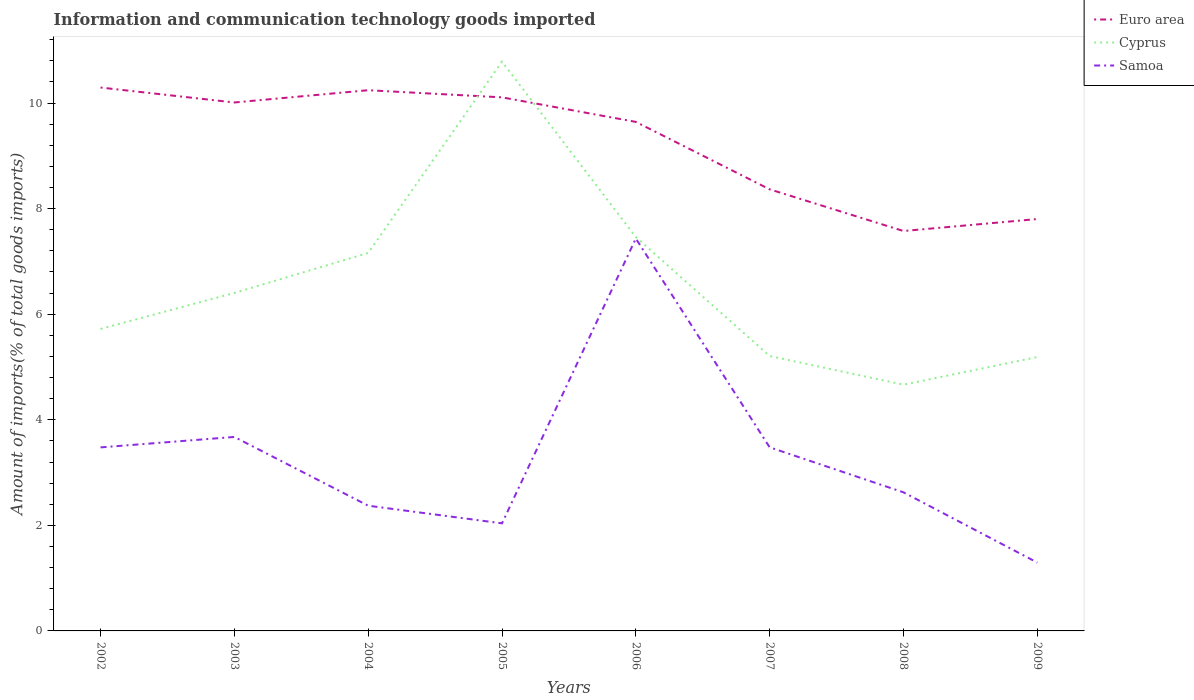How many different coloured lines are there?
Provide a succinct answer. 3. Across all years, what is the maximum amount of goods imported in Euro area?
Provide a short and direct response. 7.58. What is the total amount of goods imported in Cyprus in the graph?
Provide a short and direct response. 6.12. What is the difference between the highest and the second highest amount of goods imported in Cyprus?
Provide a short and direct response. 6.12. What is the difference between the highest and the lowest amount of goods imported in Samoa?
Ensure brevity in your answer.  4. How are the legend labels stacked?
Give a very brief answer. Vertical. What is the title of the graph?
Offer a very short reply. Information and communication technology goods imported. What is the label or title of the Y-axis?
Offer a terse response. Amount of imports(% of total goods imports). What is the Amount of imports(% of total goods imports) in Euro area in 2002?
Offer a very short reply. 10.29. What is the Amount of imports(% of total goods imports) of Cyprus in 2002?
Your answer should be very brief. 5.72. What is the Amount of imports(% of total goods imports) of Samoa in 2002?
Offer a very short reply. 3.48. What is the Amount of imports(% of total goods imports) of Euro area in 2003?
Your answer should be compact. 10.01. What is the Amount of imports(% of total goods imports) of Cyprus in 2003?
Offer a very short reply. 6.4. What is the Amount of imports(% of total goods imports) in Samoa in 2003?
Offer a terse response. 3.67. What is the Amount of imports(% of total goods imports) of Euro area in 2004?
Provide a succinct answer. 10.24. What is the Amount of imports(% of total goods imports) of Cyprus in 2004?
Provide a succinct answer. 7.16. What is the Amount of imports(% of total goods imports) of Samoa in 2004?
Keep it short and to the point. 2.37. What is the Amount of imports(% of total goods imports) in Euro area in 2005?
Provide a succinct answer. 10.11. What is the Amount of imports(% of total goods imports) of Cyprus in 2005?
Make the answer very short. 10.78. What is the Amount of imports(% of total goods imports) in Samoa in 2005?
Provide a succinct answer. 2.04. What is the Amount of imports(% of total goods imports) of Euro area in 2006?
Your response must be concise. 9.64. What is the Amount of imports(% of total goods imports) in Cyprus in 2006?
Your answer should be compact. 7.46. What is the Amount of imports(% of total goods imports) of Samoa in 2006?
Offer a very short reply. 7.43. What is the Amount of imports(% of total goods imports) in Euro area in 2007?
Keep it short and to the point. 8.37. What is the Amount of imports(% of total goods imports) of Cyprus in 2007?
Provide a short and direct response. 5.21. What is the Amount of imports(% of total goods imports) in Samoa in 2007?
Provide a short and direct response. 3.48. What is the Amount of imports(% of total goods imports) in Euro area in 2008?
Offer a terse response. 7.58. What is the Amount of imports(% of total goods imports) of Cyprus in 2008?
Provide a short and direct response. 4.66. What is the Amount of imports(% of total goods imports) of Samoa in 2008?
Provide a short and direct response. 2.63. What is the Amount of imports(% of total goods imports) of Euro area in 2009?
Give a very brief answer. 7.8. What is the Amount of imports(% of total goods imports) of Cyprus in 2009?
Give a very brief answer. 5.19. What is the Amount of imports(% of total goods imports) in Samoa in 2009?
Provide a short and direct response. 1.29. Across all years, what is the maximum Amount of imports(% of total goods imports) of Euro area?
Make the answer very short. 10.29. Across all years, what is the maximum Amount of imports(% of total goods imports) in Cyprus?
Keep it short and to the point. 10.78. Across all years, what is the maximum Amount of imports(% of total goods imports) of Samoa?
Offer a very short reply. 7.43. Across all years, what is the minimum Amount of imports(% of total goods imports) of Euro area?
Your answer should be very brief. 7.58. Across all years, what is the minimum Amount of imports(% of total goods imports) in Cyprus?
Your response must be concise. 4.66. Across all years, what is the minimum Amount of imports(% of total goods imports) of Samoa?
Offer a terse response. 1.29. What is the total Amount of imports(% of total goods imports) of Euro area in the graph?
Make the answer very short. 74.04. What is the total Amount of imports(% of total goods imports) in Cyprus in the graph?
Offer a very short reply. 52.59. What is the total Amount of imports(% of total goods imports) in Samoa in the graph?
Ensure brevity in your answer.  26.39. What is the difference between the Amount of imports(% of total goods imports) of Euro area in 2002 and that in 2003?
Your answer should be compact. 0.28. What is the difference between the Amount of imports(% of total goods imports) of Cyprus in 2002 and that in 2003?
Provide a short and direct response. -0.68. What is the difference between the Amount of imports(% of total goods imports) of Samoa in 2002 and that in 2003?
Offer a terse response. -0.2. What is the difference between the Amount of imports(% of total goods imports) of Euro area in 2002 and that in 2004?
Provide a succinct answer. 0.05. What is the difference between the Amount of imports(% of total goods imports) in Cyprus in 2002 and that in 2004?
Give a very brief answer. -1.44. What is the difference between the Amount of imports(% of total goods imports) in Samoa in 2002 and that in 2004?
Your answer should be compact. 1.1. What is the difference between the Amount of imports(% of total goods imports) in Euro area in 2002 and that in 2005?
Offer a terse response. 0.19. What is the difference between the Amount of imports(% of total goods imports) of Cyprus in 2002 and that in 2005?
Provide a succinct answer. -5.06. What is the difference between the Amount of imports(% of total goods imports) of Samoa in 2002 and that in 2005?
Provide a succinct answer. 1.44. What is the difference between the Amount of imports(% of total goods imports) of Euro area in 2002 and that in 2006?
Ensure brevity in your answer.  0.65. What is the difference between the Amount of imports(% of total goods imports) of Cyprus in 2002 and that in 2006?
Offer a very short reply. -1.74. What is the difference between the Amount of imports(% of total goods imports) of Samoa in 2002 and that in 2006?
Ensure brevity in your answer.  -3.96. What is the difference between the Amount of imports(% of total goods imports) of Euro area in 2002 and that in 2007?
Make the answer very short. 1.93. What is the difference between the Amount of imports(% of total goods imports) of Cyprus in 2002 and that in 2007?
Keep it short and to the point. 0.51. What is the difference between the Amount of imports(% of total goods imports) of Samoa in 2002 and that in 2007?
Ensure brevity in your answer.  -0. What is the difference between the Amount of imports(% of total goods imports) of Euro area in 2002 and that in 2008?
Give a very brief answer. 2.72. What is the difference between the Amount of imports(% of total goods imports) in Cyprus in 2002 and that in 2008?
Make the answer very short. 1.06. What is the difference between the Amount of imports(% of total goods imports) in Samoa in 2002 and that in 2008?
Offer a very short reply. 0.85. What is the difference between the Amount of imports(% of total goods imports) of Euro area in 2002 and that in 2009?
Offer a very short reply. 2.49. What is the difference between the Amount of imports(% of total goods imports) in Cyprus in 2002 and that in 2009?
Your answer should be compact. 0.53. What is the difference between the Amount of imports(% of total goods imports) of Samoa in 2002 and that in 2009?
Offer a terse response. 2.18. What is the difference between the Amount of imports(% of total goods imports) in Euro area in 2003 and that in 2004?
Offer a very short reply. -0.23. What is the difference between the Amount of imports(% of total goods imports) in Cyprus in 2003 and that in 2004?
Your answer should be very brief. -0.76. What is the difference between the Amount of imports(% of total goods imports) in Samoa in 2003 and that in 2004?
Make the answer very short. 1.3. What is the difference between the Amount of imports(% of total goods imports) of Euro area in 2003 and that in 2005?
Ensure brevity in your answer.  -0.1. What is the difference between the Amount of imports(% of total goods imports) of Cyprus in 2003 and that in 2005?
Provide a short and direct response. -4.38. What is the difference between the Amount of imports(% of total goods imports) in Samoa in 2003 and that in 2005?
Offer a very short reply. 1.64. What is the difference between the Amount of imports(% of total goods imports) of Euro area in 2003 and that in 2006?
Provide a short and direct response. 0.37. What is the difference between the Amount of imports(% of total goods imports) in Cyprus in 2003 and that in 2006?
Your answer should be very brief. -1.06. What is the difference between the Amount of imports(% of total goods imports) in Samoa in 2003 and that in 2006?
Provide a short and direct response. -3.76. What is the difference between the Amount of imports(% of total goods imports) in Euro area in 2003 and that in 2007?
Provide a short and direct response. 1.65. What is the difference between the Amount of imports(% of total goods imports) of Cyprus in 2003 and that in 2007?
Your answer should be very brief. 1.2. What is the difference between the Amount of imports(% of total goods imports) in Samoa in 2003 and that in 2007?
Offer a terse response. 0.2. What is the difference between the Amount of imports(% of total goods imports) in Euro area in 2003 and that in 2008?
Your answer should be very brief. 2.43. What is the difference between the Amount of imports(% of total goods imports) of Cyprus in 2003 and that in 2008?
Ensure brevity in your answer.  1.74. What is the difference between the Amount of imports(% of total goods imports) of Samoa in 2003 and that in 2008?
Keep it short and to the point. 1.05. What is the difference between the Amount of imports(% of total goods imports) in Euro area in 2003 and that in 2009?
Your answer should be compact. 2.21. What is the difference between the Amount of imports(% of total goods imports) in Cyprus in 2003 and that in 2009?
Provide a short and direct response. 1.22. What is the difference between the Amount of imports(% of total goods imports) in Samoa in 2003 and that in 2009?
Keep it short and to the point. 2.38. What is the difference between the Amount of imports(% of total goods imports) of Euro area in 2004 and that in 2005?
Ensure brevity in your answer.  0.14. What is the difference between the Amount of imports(% of total goods imports) of Cyprus in 2004 and that in 2005?
Provide a succinct answer. -3.62. What is the difference between the Amount of imports(% of total goods imports) of Samoa in 2004 and that in 2005?
Keep it short and to the point. 0.33. What is the difference between the Amount of imports(% of total goods imports) in Euro area in 2004 and that in 2006?
Your answer should be compact. 0.6. What is the difference between the Amount of imports(% of total goods imports) of Cyprus in 2004 and that in 2006?
Provide a succinct answer. -0.3. What is the difference between the Amount of imports(% of total goods imports) in Samoa in 2004 and that in 2006?
Give a very brief answer. -5.06. What is the difference between the Amount of imports(% of total goods imports) of Euro area in 2004 and that in 2007?
Ensure brevity in your answer.  1.88. What is the difference between the Amount of imports(% of total goods imports) of Cyprus in 2004 and that in 2007?
Ensure brevity in your answer.  1.95. What is the difference between the Amount of imports(% of total goods imports) of Samoa in 2004 and that in 2007?
Offer a very short reply. -1.11. What is the difference between the Amount of imports(% of total goods imports) of Euro area in 2004 and that in 2008?
Keep it short and to the point. 2.67. What is the difference between the Amount of imports(% of total goods imports) of Cyprus in 2004 and that in 2008?
Give a very brief answer. 2.5. What is the difference between the Amount of imports(% of total goods imports) of Samoa in 2004 and that in 2008?
Offer a very short reply. -0.25. What is the difference between the Amount of imports(% of total goods imports) in Euro area in 2004 and that in 2009?
Offer a terse response. 2.44. What is the difference between the Amount of imports(% of total goods imports) of Cyprus in 2004 and that in 2009?
Your answer should be very brief. 1.97. What is the difference between the Amount of imports(% of total goods imports) in Samoa in 2004 and that in 2009?
Your answer should be very brief. 1.08. What is the difference between the Amount of imports(% of total goods imports) in Euro area in 2005 and that in 2006?
Make the answer very short. 0.46. What is the difference between the Amount of imports(% of total goods imports) of Cyprus in 2005 and that in 2006?
Give a very brief answer. 3.32. What is the difference between the Amount of imports(% of total goods imports) in Samoa in 2005 and that in 2006?
Make the answer very short. -5.4. What is the difference between the Amount of imports(% of total goods imports) of Euro area in 2005 and that in 2007?
Keep it short and to the point. 1.74. What is the difference between the Amount of imports(% of total goods imports) in Cyprus in 2005 and that in 2007?
Your response must be concise. 5.58. What is the difference between the Amount of imports(% of total goods imports) in Samoa in 2005 and that in 2007?
Give a very brief answer. -1.44. What is the difference between the Amount of imports(% of total goods imports) of Euro area in 2005 and that in 2008?
Offer a terse response. 2.53. What is the difference between the Amount of imports(% of total goods imports) in Cyprus in 2005 and that in 2008?
Your answer should be compact. 6.12. What is the difference between the Amount of imports(% of total goods imports) in Samoa in 2005 and that in 2008?
Make the answer very short. -0.59. What is the difference between the Amount of imports(% of total goods imports) in Euro area in 2005 and that in 2009?
Your response must be concise. 2.31. What is the difference between the Amount of imports(% of total goods imports) in Cyprus in 2005 and that in 2009?
Provide a succinct answer. 5.6. What is the difference between the Amount of imports(% of total goods imports) of Samoa in 2005 and that in 2009?
Ensure brevity in your answer.  0.74. What is the difference between the Amount of imports(% of total goods imports) in Euro area in 2006 and that in 2007?
Provide a succinct answer. 1.28. What is the difference between the Amount of imports(% of total goods imports) in Cyprus in 2006 and that in 2007?
Your response must be concise. 2.25. What is the difference between the Amount of imports(% of total goods imports) in Samoa in 2006 and that in 2007?
Ensure brevity in your answer.  3.96. What is the difference between the Amount of imports(% of total goods imports) in Euro area in 2006 and that in 2008?
Keep it short and to the point. 2.07. What is the difference between the Amount of imports(% of total goods imports) of Cyprus in 2006 and that in 2008?
Keep it short and to the point. 2.8. What is the difference between the Amount of imports(% of total goods imports) in Samoa in 2006 and that in 2008?
Provide a short and direct response. 4.81. What is the difference between the Amount of imports(% of total goods imports) of Euro area in 2006 and that in 2009?
Your answer should be very brief. 1.84. What is the difference between the Amount of imports(% of total goods imports) of Cyprus in 2006 and that in 2009?
Provide a short and direct response. 2.27. What is the difference between the Amount of imports(% of total goods imports) in Samoa in 2006 and that in 2009?
Give a very brief answer. 6.14. What is the difference between the Amount of imports(% of total goods imports) in Euro area in 2007 and that in 2008?
Your answer should be very brief. 0.79. What is the difference between the Amount of imports(% of total goods imports) in Cyprus in 2007 and that in 2008?
Provide a succinct answer. 0.54. What is the difference between the Amount of imports(% of total goods imports) in Samoa in 2007 and that in 2008?
Give a very brief answer. 0.85. What is the difference between the Amount of imports(% of total goods imports) in Euro area in 2007 and that in 2009?
Keep it short and to the point. 0.56. What is the difference between the Amount of imports(% of total goods imports) of Cyprus in 2007 and that in 2009?
Your answer should be compact. 0.02. What is the difference between the Amount of imports(% of total goods imports) in Samoa in 2007 and that in 2009?
Offer a terse response. 2.18. What is the difference between the Amount of imports(% of total goods imports) in Euro area in 2008 and that in 2009?
Your answer should be very brief. -0.23. What is the difference between the Amount of imports(% of total goods imports) in Cyprus in 2008 and that in 2009?
Provide a short and direct response. -0.52. What is the difference between the Amount of imports(% of total goods imports) of Samoa in 2008 and that in 2009?
Offer a terse response. 1.33. What is the difference between the Amount of imports(% of total goods imports) of Euro area in 2002 and the Amount of imports(% of total goods imports) of Cyprus in 2003?
Ensure brevity in your answer.  3.89. What is the difference between the Amount of imports(% of total goods imports) in Euro area in 2002 and the Amount of imports(% of total goods imports) in Samoa in 2003?
Your response must be concise. 6.62. What is the difference between the Amount of imports(% of total goods imports) of Cyprus in 2002 and the Amount of imports(% of total goods imports) of Samoa in 2003?
Keep it short and to the point. 2.05. What is the difference between the Amount of imports(% of total goods imports) in Euro area in 2002 and the Amount of imports(% of total goods imports) in Cyprus in 2004?
Give a very brief answer. 3.13. What is the difference between the Amount of imports(% of total goods imports) of Euro area in 2002 and the Amount of imports(% of total goods imports) of Samoa in 2004?
Make the answer very short. 7.92. What is the difference between the Amount of imports(% of total goods imports) in Cyprus in 2002 and the Amount of imports(% of total goods imports) in Samoa in 2004?
Provide a succinct answer. 3.35. What is the difference between the Amount of imports(% of total goods imports) of Euro area in 2002 and the Amount of imports(% of total goods imports) of Cyprus in 2005?
Offer a very short reply. -0.49. What is the difference between the Amount of imports(% of total goods imports) of Euro area in 2002 and the Amount of imports(% of total goods imports) of Samoa in 2005?
Provide a succinct answer. 8.26. What is the difference between the Amount of imports(% of total goods imports) in Cyprus in 2002 and the Amount of imports(% of total goods imports) in Samoa in 2005?
Give a very brief answer. 3.68. What is the difference between the Amount of imports(% of total goods imports) in Euro area in 2002 and the Amount of imports(% of total goods imports) in Cyprus in 2006?
Make the answer very short. 2.83. What is the difference between the Amount of imports(% of total goods imports) in Euro area in 2002 and the Amount of imports(% of total goods imports) in Samoa in 2006?
Ensure brevity in your answer.  2.86. What is the difference between the Amount of imports(% of total goods imports) in Cyprus in 2002 and the Amount of imports(% of total goods imports) in Samoa in 2006?
Your response must be concise. -1.71. What is the difference between the Amount of imports(% of total goods imports) in Euro area in 2002 and the Amount of imports(% of total goods imports) in Cyprus in 2007?
Give a very brief answer. 5.09. What is the difference between the Amount of imports(% of total goods imports) of Euro area in 2002 and the Amount of imports(% of total goods imports) of Samoa in 2007?
Your answer should be compact. 6.82. What is the difference between the Amount of imports(% of total goods imports) of Cyprus in 2002 and the Amount of imports(% of total goods imports) of Samoa in 2007?
Provide a succinct answer. 2.24. What is the difference between the Amount of imports(% of total goods imports) of Euro area in 2002 and the Amount of imports(% of total goods imports) of Cyprus in 2008?
Your answer should be very brief. 5.63. What is the difference between the Amount of imports(% of total goods imports) of Euro area in 2002 and the Amount of imports(% of total goods imports) of Samoa in 2008?
Provide a succinct answer. 7.67. What is the difference between the Amount of imports(% of total goods imports) of Cyprus in 2002 and the Amount of imports(% of total goods imports) of Samoa in 2008?
Provide a short and direct response. 3.1. What is the difference between the Amount of imports(% of total goods imports) of Euro area in 2002 and the Amount of imports(% of total goods imports) of Cyprus in 2009?
Offer a terse response. 5.11. What is the difference between the Amount of imports(% of total goods imports) of Euro area in 2002 and the Amount of imports(% of total goods imports) of Samoa in 2009?
Ensure brevity in your answer.  9. What is the difference between the Amount of imports(% of total goods imports) of Cyprus in 2002 and the Amount of imports(% of total goods imports) of Samoa in 2009?
Provide a succinct answer. 4.43. What is the difference between the Amount of imports(% of total goods imports) of Euro area in 2003 and the Amount of imports(% of total goods imports) of Cyprus in 2004?
Offer a terse response. 2.85. What is the difference between the Amount of imports(% of total goods imports) of Euro area in 2003 and the Amount of imports(% of total goods imports) of Samoa in 2004?
Your answer should be very brief. 7.64. What is the difference between the Amount of imports(% of total goods imports) of Cyprus in 2003 and the Amount of imports(% of total goods imports) of Samoa in 2004?
Provide a short and direct response. 4.03. What is the difference between the Amount of imports(% of total goods imports) of Euro area in 2003 and the Amount of imports(% of total goods imports) of Cyprus in 2005?
Give a very brief answer. -0.77. What is the difference between the Amount of imports(% of total goods imports) in Euro area in 2003 and the Amount of imports(% of total goods imports) in Samoa in 2005?
Offer a terse response. 7.97. What is the difference between the Amount of imports(% of total goods imports) in Cyprus in 2003 and the Amount of imports(% of total goods imports) in Samoa in 2005?
Provide a succinct answer. 4.36. What is the difference between the Amount of imports(% of total goods imports) in Euro area in 2003 and the Amount of imports(% of total goods imports) in Cyprus in 2006?
Offer a very short reply. 2.55. What is the difference between the Amount of imports(% of total goods imports) in Euro area in 2003 and the Amount of imports(% of total goods imports) in Samoa in 2006?
Your answer should be very brief. 2.58. What is the difference between the Amount of imports(% of total goods imports) of Cyprus in 2003 and the Amount of imports(% of total goods imports) of Samoa in 2006?
Your answer should be very brief. -1.03. What is the difference between the Amount of imports(% of total goods imports) of Euro area in 2003 and the Amount of imports(% of total goods imports) of Cyprus in 2007?
Your answer should be very brief. 4.8. What is the difference between the Amount of imports(% of total goods imports) of Euro area in 2003 and the Amount of imports(% of total goods imports) of Samoa in 2007?
Keep it short and to the point. 6.53. What is the difference between the Amount of imports(% of total goods imports) of Cyprus in 2003 and the Amount of imports(% of total goods imports) of Samoa in 2007?
Ensure brevity in your answer.  2.92. What is the difference between the Amount of imports(% of total goods imports) of Euro area in 2003 and the Amount of imports(% of total goods imports) of Cyprus in 2008?
Your answer should be compact. 5.35. What is the difference between the Amount of imports(% of total goods imports) of Euro area in 2003 and the Amount of imports(% of total goods imports) of Samoa in 2008?
Give a very brief answer. 7.39. What is the difference between the Amount of imports(% of total goods imports) of Cyprus in 2003 and the Amount of imports(% of total goods imports) of Samoa in 2008?
Offer a very short reply. 3.78. What is the difference between the Amount of imports(% of total goods imports) in Euro area in 2003 and the Amount of imports(% of total goods imports) in Cyprus in 2009?
Ensure brevity in your answer.  4.82. What is the difference between the Amount of imports(% of total goods imports) of Euro area in 2003 and the Amount of imports(% of total goods imports) of Samoa in 2009?
Ensure brevity in your answer.  8.72. What is the difference between the Amount of imports(% of total goods imports) in Cyprus in 2003 and the Amount of imports(% of total goods imports) in Samoa in 2009?
Your answer should be very brief. 5.11. What is the difference between the Amount of imports(% of total goods imports) in Euro area in 2004 and the Amount of imports(% of total goods imports) in Cyprus in 2005?
Provide a succinct answer. -0.54. What is the difference between the Amount of imports(% of total goods imports) in Euro area in 2004 and the Amount of imports(% of total goods imports) in Samoa in 2005?
Your response must be concise. 8.21. What is the difference between the Amount of imports(% of total goods imports) in Cyprus in 2004 and the Amount of imports(% of total goods imports) in Samoa in 2005?
Provide a succinct answer. 5.12. What is the difference between the Amount of imports(% of total goods imports) in Euro area in 2004 and the Amount of imports(% of total goods imports) in Cyprus in 2006?
Your response must be concise. 2.78. What is the difference between the Amount of imports(% of total goods imports) of Euro area in 2004 and the Amount of imports(% of total goods imports) of Samoa in 2006?
Ensure brevity in your answer.  2.81. What is the difference between the Amount of imports(% of total goods imports) in Cyprus in 2004 and the Amount of imports(% of total goods imports) in Samoa in 2006?
Offer a very short reply. -0.27. What is the difference between the Amount of imports(% of total goods imports) of Euro area in 2004 and the Amount of imports(% of total goods imports) of Cyprus in 2007?
Your answer should be compact. 5.04. What is the difference between the Amount of imports(% of total goods imports) in Euro area in 2004 and the Amount of imports(% of total goods imports) in Samoa in 2007?
Provide a short and direct response. 6.76. What is the difference between the Amount of imports(% of total goods imports) of Cyprus in 2004 and the Amount of imports(% of total goods imports) of Samoa in 2007?
Your response must be concise. 3.68. What is the difference between the Amount of imports(% of total goods imports) of Euro area in 2004 and the Amount of imports(% of total goods imports) of Cyprus in 2008?
Ensure brevity in your answer.  5.58. What is the difference between the Amount of imports(% of total goods imports) in Euro area in 2004 and the Amount of imports(% of total goods imports) in Samoa in 2008?
Ensure brevity in your answer.  7.62. What is the difference between the Amount of imports(% of total goods imports) in Cyprus in 2004 and the Amount of imports(% of total goods imports) in Samoa in 2008?
Your response must be concise. 4.53. What is the difference between the Amount of imports(% of total goods imports) of Euro area in 2004 and the Amount of imports(% of total goods imports) of Cyprus in 2009?
Offer a terse response. 5.06. What is the difference between the Amount of imports(% of total goods imports) in Euro area in 2004 and the Amount of imports(% of total goods imports) in Samoa in 2009?
Offer a terse response. 8.95. What is the difference between the Amount of imports(% of total goods imports) of Cyprus in 2004 and the Amount of imports(% of total goods imports) of Samoa in 2009?
Provide a short and direct response. 5.87. What is the difference between the Amount of imports(% of total goods imports) of Euro area in 2005 and the Amount of imports(% of total goods imports) of Cyprus in 2006?
Your response must be concise. 2.65. What is the difference between the Amount of imports(% of total goods imports) of Euro area in 2005 and the Amount of imports(% of total goods imports) of Samoa in 2006?
Provide a succinct answer. 2.67. What is the difference between the Amount of imports(% of total goods imports) in Cyprus in 2005 and the Amount of imports(% of total goods imports) in Samoa in 2006?
Ensure brevity in your answer.  3.35. What is the difference between the Amount of imports(% of total goods imports) in Euro area in 2005 and the Amount of imports(% of total goods imports) in Cyprus in 2007?
Give a very brief answer. 4.9. What is the difference between the Amount of imports(% of total goods imports) in Euro area in 2005 and the Amount of imports(% of total goods imports) in Samoa in 2007?
Give a very brief answer. 6.63. What is the difference between the Amount of imports(% of total goods imports) in Cyprus in 2005 and the Amount of imports(% of total goods imports) in Samoa in 2007?
Provide a short and direct response. 7.31. What is the difference between the Amount of imports(% of total goods imports) of Euro area in 2005 and the Amount of imports(% of total goods imports) of Cyprus in 2008?
Offer a very short reply. 5.44. What is the difference between the Amount of imports(% of total goods imports) of Euro area in 2005 and the Amount of imports(% of total goods imports) of Samoa in 2008?
Make the answer very short. 7.48. What is the difference between the Amount of imports(% of total goods imports) in Cyprus in 2005 and the Amount of imports(% of total goods imports) in Samoa in 2008?
Give a very brief answer. 8.16. What is the difference between the Amount of imports(% of total goods imports) in Euro area in 2005 and the Amount of imports(% of total goods imports) in Cyprus in 2009?
Keep it short and to the point. 4.92. What is the difference between the Amount of imports(% of total goods imports) in Euro area in 2005 and the Amount of imports(% of total goods imports) in Samoa in 2009?
Keep it short and to the point. 8.81. What is the difference between the Amount of imports(% of total goods imports) in Cyprus in 2005 and the Amount of imports(% of total goods imports) in Samoa in 2009?
Offer a terse response. 9.49. What is the difference between the Amount of imports(% of total goods imports) of Euro area in 2006 and the Amount of imports(% of total goods imports) of Cyprus in 2007?
Your response must be concise. 4.44. What is the difference between the Amount of imports(% of total goods imports) in Euro area in 2006 and the Amount of imports(% of total goods imports) in Samoa in 2007?
Offer a very short reply. 6.17. What is the difference between the Amount of imports(% of total goods imports) in Cyprus in 2006 and the Amount of imports(% of total goods imports) in Samoa in 2007?
Your response must be concise. 3.98. What is the difference between the Amount of imports(% of total goods imports) of Euro area in 2006 and the Amount of imports(% of total goods imports) of Cyprus in 2008?
Keep it short and to the point. 4.98. What is the difference between the Amount of imports(% of total goods imports) in Euro area in 2006 and the Amount of imports(% of total goods imports) in Samoa in 2008?
Provide a short and direct response. 7.02. What is the difference between the Amount of imports(% of total goods imports) of Cyprus in 2006 and the Amount of imports(% of total goods imports) of Samoa in 2008?
Make the answer very short. 4.84. What is the difference between the Amount of imports(% of total goods imports) in Euro area in 2006 and the Amount of imports(% of total goods imports) in Cyprus in 2009?
Your response must be concise. 4.46. What is the difference between the Amount of imports(% of total goods imports) of Euro area in 2006 and the Amount of imports(% of total goods imports) of Samoa in 2009?
Your response must be concise. 8.35. What is the difference between the Amount of imports(% of total goods imports) of Cyprus in 2006 and the Amount of imports(% of total goods imports) of Samoa in 2009?
Offer a very short reply. 6.17. What is the difference between the Amount of imports(% of total goods imports) in Euro area in 2007 and the Amount of imports(% of total goods imports) in Cyprus in 2008?
Provide a short and direct response. 3.7. What is the difference between the Amount of imports(% of total goods imports) in Euro area in 2007 and the Amount of imports(% of total goods imports) in Samoa in 2008?
Provide a succinct answer. 5.74. What is the difference between the Amount of imports(% of total goods imports) in Cyprus in 2007 and the Amount of imports(% of total goods imports) in Samoa in 2008?
Make the answer very short. 2.58. What is the difference between the Amount of imports(% of total goods imports) in Euro area in 2007 and the Amount of imports(% of total goods imports) in Cyprus in 2009?
Ensure brevity in your answer.  3.18. What is the difference between the Amount of imports(% of total goods imports) in Euro area in 2007 and the Amount of imports(% of total goods imports) in Samoa in 2009?
Your answer should be compact. 7.07. What is the difference between the Amount of imports(% of total goods imports) of Cyprus in 2007 and the Amount of imports(% of total goods imports) of Samoa in 2009?
Offer a terse response. 3.91. What is the difference between the Amount of imports(% of total goods imports) of Euro area in 2008 and the Amount of imports(% of total goods imports) of Cyprus in 2009?
Give a very brief answer. 2.39. What is the difference between the Amount of imports(% of total goods imports) in Euro area in 2008 and the Amount of imports(% of total goods imports) in Samoa in 2009?
Provide a succinct answer. 6.28. What is the difference between the Amount of imports(% of total goods imports) of Cyprus in 2008 and the Amount of imports(% of total goods imports) of Samoa in 2009?
Your response must be concise. 3.37. What is the average Amount of imports(% of total goods imports) in Euro area per year?
Your answer should be very brief. 9.26. What is the average Amount of imports(% of total goods imports) in Cyprus per year?
Your answer should be compact. 6.57. What is the average Amount of imports(% of total goods imports) of Samoa per year?
Keep it short and to the point. 3.3. In the year 2002, what is the difference between the Amount of imports(% of total goods imports) in Euro area and Amount of imports(% of total goods imports) in Cyprus?
Ensure brevity in your answer.  4.57. In the year 2002, what is the difference between the Amount of imports(% of total goods imports) of Euro area and Amount of imports(% of total goods imports) of Samoa?
Your answer should be very brief. 6.82. In the year 2002, what is the difference between the Amount of imports(% of total goods imports) of Cyprus and Amount of imports(% of total goods imports) of Samoa?
Ensure brevity in your answer.  2.24. In the year 2003, what is the difference between the Amount of imports(% of total goods imports) in Euro area and Amount of imports(% of total goods imports) in Cyprus?
Make the answer very short. 3.61. In the year 2003, what is the difference between the Amount of imports(% of total goods imports) of Euro area and Amount of imports(% of total goods imports) of Samoa?
Provide a succinct answer. 6.34. In the year 2003, what is the difference between the Amount of imports(% of total goods imports) of Cyprus and Amount of imports(% of total goods imports) of Samoa?
Keep it short and to the point. 2.73. In the year 2004, what is the difference between the Amount of imports(% of total goods imports) in Euro area and Amount of imports(% of total goods imports) in Cyprus?
Give a very brief answer. 3.08. In the year 2004, what is the difference between the Amount of imports(% of total goods imports) in Euro area and Amount of imports(% of total goods imports) in Samoa?
Give a very brief answer. 7.87. In the year 2004, what is the difference between the Amount of imports(% of total goods imports) of Cyprus and Amount of imports(% of total goods imports) of Samoa?
Provide a short and direct response. 4.79. In the year 2005, what is the difference between the Amount of imports(% of total goods imports) of Euro area and Amount of imports(% of total goods imports) of Cyprus?
Offer a terse response. -0.68. In the year 2005, what is the difference between the Amount of imports(% of total goods imports) in Euro area and Amount of imports(% of total goods imports) in Samoa?
Give a very brief answer. 8.07. In the year 2005, what is the difference between the Amount of imports(% of total goods imports) of Cyprus and Amount of imports(% of total goods imports) of Samoa?
Offer a terse response. 8.75. In the year 2006, what is the difference between the Amount of imports(% of total goods imports) in Euro area and Amount of imports(% of total goods imports) in Cyprus?
Your answer should be compact. 2.18. In the year 2006, what is the difference between the Amount of imports(% of total goods imports) in Euro area and Amount of imports(% of total goods imports) in Samoa?
Your response must be concise. 2.21. In the year 2006, what is the difference between the Amount of imports(% of total goods imports) in Cyprus and Amount of imports(% of total goods imports) in Samoa?
Make the answer very short. 0.03. In the year 2007, what is the difference between the Amount of imports(% of total goods imports) in Euro area and Amount of imports(% of total goods imports) in Cyprus?
Give a very brief answer. 3.16. In the year 2007, what is the difference between the Amount of imports(% of total goods imports) of Euro area and Amount of imports(% of total goods imports) of Samoa?
Make the answer very short. 4.89. In the year 2007, what is the difference between the Amount of imports(% of total goods imports) of Cyprus and Amount of imports(% of total goods imports) of Samoa?
Offer a terse response. 1.73. In the year 2008, what is the difference between the Amount of imports(% of total goods imports) of Euro area and Amount of imports(% of total goods imports) of Cyprus?
Your answer should be compact. 2.91. In the year 2008, what is the difference between the Amount of imports(% of total goods imports) in Euro area and Amount of imports(% of total goods imports) in Samoa?
Your answer should be compact. 4.95. In the year 2008, what is the difference between the Amount of imports(% of total goods imports) in Cyprus and Amount of imports(% of total goods imports) in Samoa?
Keep it short and to the point. 2.04. In the year 2009, what is the difference between the Amount of imports(% of total goods imports) in Euro area and Amount of imports(% of total goods imports) in Cyprus?
Ensure brevity in your answer.  2.61. In the year 2009, what is the difference between the Amount of imports(% of total goods imports) of Euro area and Amount of imports(% of total goods imports) of Samoa?
Your answer should be very brief. 6.51. In the year 2009, what is the difference between the Amount of imports(% of total goods imports) of Cyprus and Amount of imports(% of total goods imports) of Samoa?
Offer a very short reply. 3.89. What is the ratio of the Amount of imports(% of total goods imports) in Euro area in 2002 to that in 2003?
Ensure brevity in your answer.  1.03. What is the ratio of the Amount of imports(% of total goods imports) in Cyprus in 2002 to that in 2003?
Your answer should be compact. 0.89. What is the ratio of the Amount of imports(% of total goods imports) of Samoa in 2002 to that in 2003?
Your response must be concise. 0.95. What is the ratio of the Amount of imports(% of total goods imports) in Cyprus in 2002 to that in 2004?
Your response must be concise. 0.8. What is the ratio of the Amount of imports(% of total goods imports) in Samoa in 2002 to that in 2004?
Your response must be concise. 1.47. What is the ratio of the Amount of imports(% of total goods imports) in Euro area in 2002 to that in 2005?
Give a very brief answer. 1.02. What is the ratio of the Amount of imports(% of total goods imports) in Cyprus in 2002 to that in 2005?
Make the answer very short. 0.53. What is the ratio of the Amount of imports(% of total goods imports) in Samoa in 2002 to that in 2005?
Your answer should be very brief. 1.71. What is the ratio of the Amount of imports(% of total goods imports) in Euro area in 2002 to that in 2006?
Ensure brevity in your answer.  1.07. What is the ratio of the Amount of imports(% of total goods imports) of Cyprus in 2002 to that in 2006?
Give a very brief answer. 0.77. What is the ratio of the Amount of imports(% of total goods imports) of Samoa in 2002 to that in 2006?
Offer a terse response. 0.47. What is the ratio of the Amount of imports(% of total goods imports) in Euro area in 2002 to that in 2007?
Your answer should be compact. 1.23. What is the ratio of the Amount of imports(% of total goods imports) of Cyprus in 2002 to that in 2007?
Your response must be concise. 1.1. What is the ratio of the Amount of imports(% of total goods imports) of Samoa in 2002 to that in 2007?
Ensure brevity in your answer.  1. What is the ratio of the Amount of imports(% of total goods imports) of Euro area in 2002 to that in 2008?
Give a very brief answer. 1.36. What is the ratio of the Amount of imports(% of total goods imports) of Cyprus in 2002 to that in 2008?
Ensure brevity in your answer.  1.23. What is the ratio of the Amount of imports(% of total goods imports) in Samoa in 2002 to that in 2008?
Give a very brief answer. 1.32. What is the ratio of the Amount of imports(% of total goods imports) of Euro area in 2002 to that in 2009?
Make the answer very short. 1.32. What is the ratio of the Amount of imports(% of total goods imports) in Cyprus in 2002 to that in 2009?
Provide a succinct answer. 1.1. What is the ratio of the Amount of imports(% of total goods imports) in Samoa in 2002 to that in 2009?
Give a very brief answer. 2.69. What is the ratio of the Amount of imports(% of total goods imports) in Euro area in 2003 to that in 2004?
Ensure brevity in your answer.  0.98. What is the ratio of the Amount of imports(% of total goods imports) in Cyprus in 2003 to that in 2004?
Give a very brief answer. 0.89. What is the ratio of the Amount of imports(% of total goods imports) of Samoa in 2003 to that in 2004?
Give a very brief answer. 1.55. What is the ratio of the Amount of imports(% of total goods imports) in Cyprus in 2003 to that in 2005?
Your answer should be compact. 0.59. What is the ratio of the Amount of imports(% of total goods imports) in Samoa in 2003 to that in 2005?
Your answer should be very brief. 1.8. What is the ratio of the Amount of imports(% of total goods imports) of Euro area in 2003 to that in 2006?
Your answer should be compact. 1.04. What is the ratio of the Amount of imports(% of total goods imports) in Cyprus in 2003 to that in 2006?
Offer a terse response. 0.86. What is the ratio of the Amount of imports(% of total goods imports) of Samoa in 2003 to that in 2006?
Provide a short and direct response. 0.49. What is the ratio of the Amount of imports(% of total goods imports) of Euro area in 2003 to that in 2007?
Keep it short and to the point. 1.2. What is the ratio of the Amount of imports(% of total goods imports) of Cyprus in 2003 to that in 2007?
Your response must be concise. 1.23. What is the ratio of the Amount of imports(% of total goods imports) of Samoa in 2003 to that in 2007?
Keep it short and to the point. 1.06. What is the ratio of the Amount of imports(% of total goods imports) in Euro area in 2003 to that in 2008?
Give a very brief answer. 1.32. What is the ratio of the Amount of imports(% of total goods imports) of Cyprus in 2003 to that in 2008?
Your answer should be compact. 1.37. What is the ratio of the Amount of imports(% of total goods imports) of Samoa in 2003 to that in 2008?
Provide a short and direct response. 1.4. What is the ratio of the Amount of imports(% of total goods imports) of Euro area in 2003 to that in 2009?
Provide a succinct answer. 1.28. What is the ratio of the Amount of imports(% of total goods imports) in Cyprus in 2003 to that in 2009?
Ensure brevity in your answer.  1.23. What is the ratio of the Amount of imports(% of total goods imports) in Samoa in 2003 to that in 2009?
Provide a short and direct response. 2.84. What is the ratio of the Amount of imports(% of total goods imports) of Euro area in 2004 to that in 2005?
Ensure brevity in your answer.  1.01. What is the ratio of the Amount of imports(% of total goods imports) of Cyprus in 2004 to that in 2005?
Provide a short and direct response. 0.66. What is the ratio of the Amount of imports(% of total goods imports) of Samoa in 2004 to that in 2005?
Provide a succinct answer. 1.16. What is the ratio of the Amount of imports(% of total goods imports) in Euro area in 2004 to that in 2006?
Keep it short and to the point. 1.06. What is the ratio of the Amount of imports(% of total goods imports) of Cyprus in 2004 to that in 2006?
Give a very brief answer. 0.96. What is the ratio of the Amount of imports(% of total goods imports) of Samoa in 2004 to that in 2006?
Keep it short and to the point. 0.32. What is the ratio of the Amount of imports(% of total goods imports) of Euro area in 2004 to that in 2007?
Your response must be concise. 1.22. What is the ratio of the Amount of imports(% of total goods imports) in Cyprus in 2004 to that in 2007?
Provide a succinct answer. 1.37. What is the ratio of the Amount of imports(% of total goods imports) in Samoa in 2004 to that in 2007?
Provide a succinct answer. 0.68. What is the ratio of the Amount of imports(% of total goods imports) of Euro area in 2004 to that in 2008?
Make the answer very short. 1.35. What is the ratio of the Amount of imports(% of total goods imports) of Cyprus in 2004 to that in 2008?
Your answer should be compact. 1.53. What is the ratio of the Amount of imports(% of total goods imports) in Samoa in 2004 to that in 2008?
Ensure brevity in your answer.  0.9. What is the ratio of the Amount of imports(% of total goods imports) of Euro area in 2004 to that in 2009?
Provide a succinct answer. 1.31. What is the ratio of the Amount of imports(% of total goods imports) of Cyprus in 2004 to that in 2009?
Your response must be concise. 1.38. What is the ratio of the Amount of imports(% of total goods imports) in Samoa in 2004 to that in 2009?
Offer a very short reply. 1.83. What is the ratio of the Amount of imports(% of total goods imports) in Euro area in 2005 to that in 2006?
Ensure brevity in your answer.  1.05. What is the ratio of the Amount of imports(% of total goods imports) of Cyprus in 2005 to that in 2006?
Your response must be concise. 1.45. What is the ratio of the Amount of imports(% of total goods imports) of Samoa in 2005 to that in 2006?
Provide a short and direct response. 0.27. What is the ratio of the Amount of imports(% of total goods imports) of Euro area in 2005 to that in 2007?
Give a very brief answer. 1.21. What is the ratio of the Amount of imports(% of total goods imports) in Cyprus in 2005 to that in 2007?
Keep it short and to the point. 2.07. What is the ratio of the Amount of imports(% of total goods imports) in Samoa in 2005 to that in 2007?
Ensure brevity in your answer.  0.59. What is the ratio of the Amount of imports(% of total goods imports) of Euro area in 2005 to that in 2008?
Ensure brevity in your answer.  1.33. What is the ratio of the Amount of imports(% of total goods imports) in Cyprus in 2005 to that in 2008?
Provide a succinct answer. 2.31. What is the ratio of the Amount of imports(% of total goods imports) in Samoa in 2005 to that in 2008?
Make the answer very short. 0.78. What is the ratio of the Amount of imports(% of total goods imports) of Euro area in 2005 to that in 2009?
Your answer should be very brief. 1.3. What is the ratio of the Amount of imports(% of total goods imports) of Cyprus in 2005 to that in 2009?
Provide a short and direct response. 2.08. What is the ratio of the Amount of imports(% of total goods imports) in Samoa in 2005 to that in 2009?
Your response must be concise. 1.57. What is the ratio of the Amount of imports(% of total goods imports) of Euro area in 2006 to that in 2007?
Your response must be concise. 1.15. What is the ratio of the Amount of imports(% of total goods imports) in Cyprus in 2006 to that in 2007?
Your answer should be very brief. 1.43. What is the ratio of the Amount of imports(% of total goods imports) in Samoa in 2006 to that in 2007?
Keep it short and to the point. 2.14. What is the ratio of the Amount of imports(% of total goods imports) in Euro area in 2006 to that in 2008?
Offer a very short reply. 1.27. What is the ratio of the Amount of imports(% of total goods imports) of Cyprus in 2006 to that in 2008?
Make the answer very short. 1.6. What is the ratio of the Amount of imports(% of total goods imports) in Samoa in 2006 to that in 2008?
Make the answer very short. 2.83. What is the ratio of the Amount of imports(% of total goods imports) in Euro area in 2006 to that in 2009?
Your answer should be compact. 1.24. What is the ratio of the Amount of imports(% of total goods imports) of Cyprus in 2006 to that in 2009?
Offer a terse response. 1.44. What is the ratio of the Amount of imports(% of total goods imports) of Samoa in 2006 to that in 2009?
Offer a very short reply. 5.74. What is the ratio of the Amount of imports(% of total goods imports) in Euro area in 2007 to that in 2008?
Ensure brevity in your answer.  1.1. What is the ratio of the Amount of imports(% of total goods imports) of Cyprus in 2007 to that in 2008?
Provide a succinct answer. 1.12. What is the ratio of the Amount of imports(% of total goods imports) of Samoa in 2007 to that in 2008?
Keep it short and to the point. 1.32. What is the ratio of the Amount of imports(% of total goods imports) in Euro area in 2007 to that in 2009?
Provide a succinct answer. 1.07. What is the ratio of the Amount of imports(% of total goods imports) of Samoa in 2007 to that in 2009?
Ensure brevity in your answer.  2.69. What is the ratio of the Amount of imports(% of total goods imports) in Euro area in 2008 to that in 2009?
Provide a short and direct response. 0.97. What is the ratio of the Amount of imports(% of total goods imports) in Cyprus in 2008 to that in 2009?
Offer a very short reply. 0.9. What is the ratio of the Amount of imports(% of total goods imports) in Samoa in 2008 to that in 2009?
Ensure brevity in your answer.  2.03. What is the difference between the highest and the second highest Amount of imports(% of total goods imports) in Euro area?
Offer a very short reply. 0.05. What is the difference between the highest and the second highest Amount of imports(% of total goods imports) in Cyprus?
Your response must be concise. 3.32. What is the difference between the highest and the second highest Amount of imports(% of total goods imports) in Samoa?
Provide a succinct answer. 3.76. What is the difference between the highest and the lowest Amount of imports(% of total goods imports) in Euro area?
Provide a short and direct response. 2.72. What is the difference between the highest and the lowest Amount of imports(% of total goods imports) of Cyprus?
Your answer should be compact. 6.12. What is the difference between the highest and the lowest Amount of imports(% of total goods imports) in Samoa?
Your answer should be compact. 6.14. 